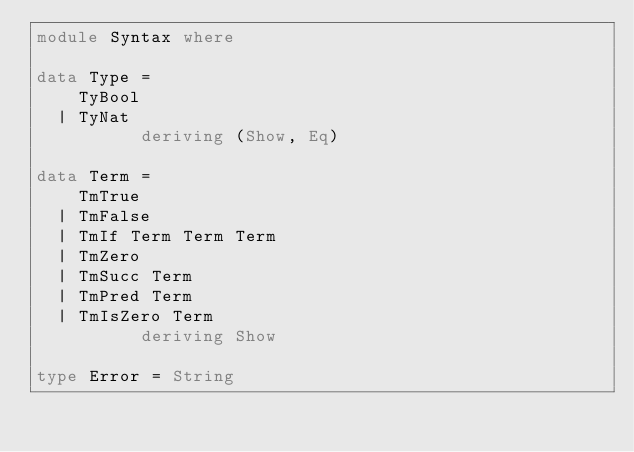<code> <loc_0><loc_0><loc_500><loc_500><_Haskell_>module Syntax where

data Type =
    TyBool
  | TyNat
          deriving (Show, Eq)

data Term =
    TmTrue
  | TmFalse
  | TmIf Term Term Term
  | TmZero
  | TmSucc Term
  | TmPred Term
  | TmIsZero Term
          deriving Show

type Error = String
</code> 